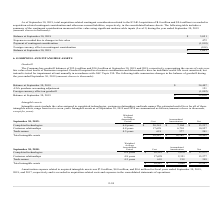According to Mitek Systems's financial document, What does intangible assets include? the value assigned to completed technologies, customer relationships, and trade names. The document states: "Intangible assets include the value assigned to completed technologies, customer relationships, and trade names. The estimated useful lives for all of..." Also, What is the range of the estimated useful lives of the intangible assets? According to the financial document, two to seven years. The relevant text states: "intangible assets, range from two to seven years. Intangible assets as of September 30, 2019 and 2018 are summarized as follows (amounts shown in th..." Also, What are the costs of completed technologies and customer relationships in 2019, respectively? The document shows two values: $20,341 and 17,628 (in thousands). From the document: "Completed technologies 6.4 years $ 20,341 $ 7,104 $ 13,237 Customer relationships 4.8 years 17,628 6,701 10,927..." Additionally, Which intangible assets have the highest proportion of accumulated amortization over cost in 2019? According to the financial document, Trade names. The relevant text states: "Trade names 4.5 years 618 377 241..." Also, can you calculate: What is the percentage constitution of the cost of customer relationships among the total cost of the total intangible assets in 2019? Based on the calculation: 17,628/38,587, the result is 45.68 (percentage). This is based on the information: "Customer relationships 4.8 years 17,628 6,701 10,927 Total intangible assets $ 38,587 $ 14,182 $ 24,405..." The key data points involved are: 17,628, 38,587. Also, can you calculate: What is the average net value of the three categories of intangible assets in 2019? To answer this question, I need to perform calculations using the financial data. The calculation is: (13,237+10,927+241)/3 , which equals 8135 (in thousands). This is based on the information: "Customer relationships 4.8 years 17,628 6,701 10,927 Trade names 4.5 years 618 377 241 mpleted technologies 6.4 years $ 20,341 $ 7,104 $ 13,237..." The key data points involved are: 10,927, 13,237, 241. 